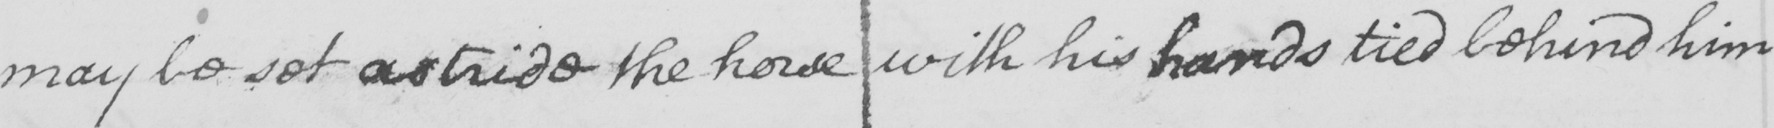Please transcribe the handwritten text in this image. may be set astride the horse with his hands tied behind him 